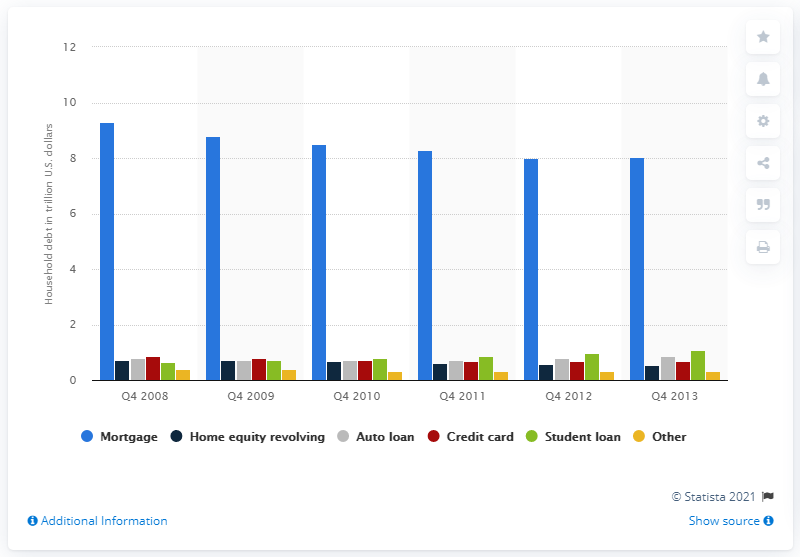Outline some significant characteristics in this image. In the fourth quarter of 2013, the amount of mortgage debt in the US was approximately 8.05. 